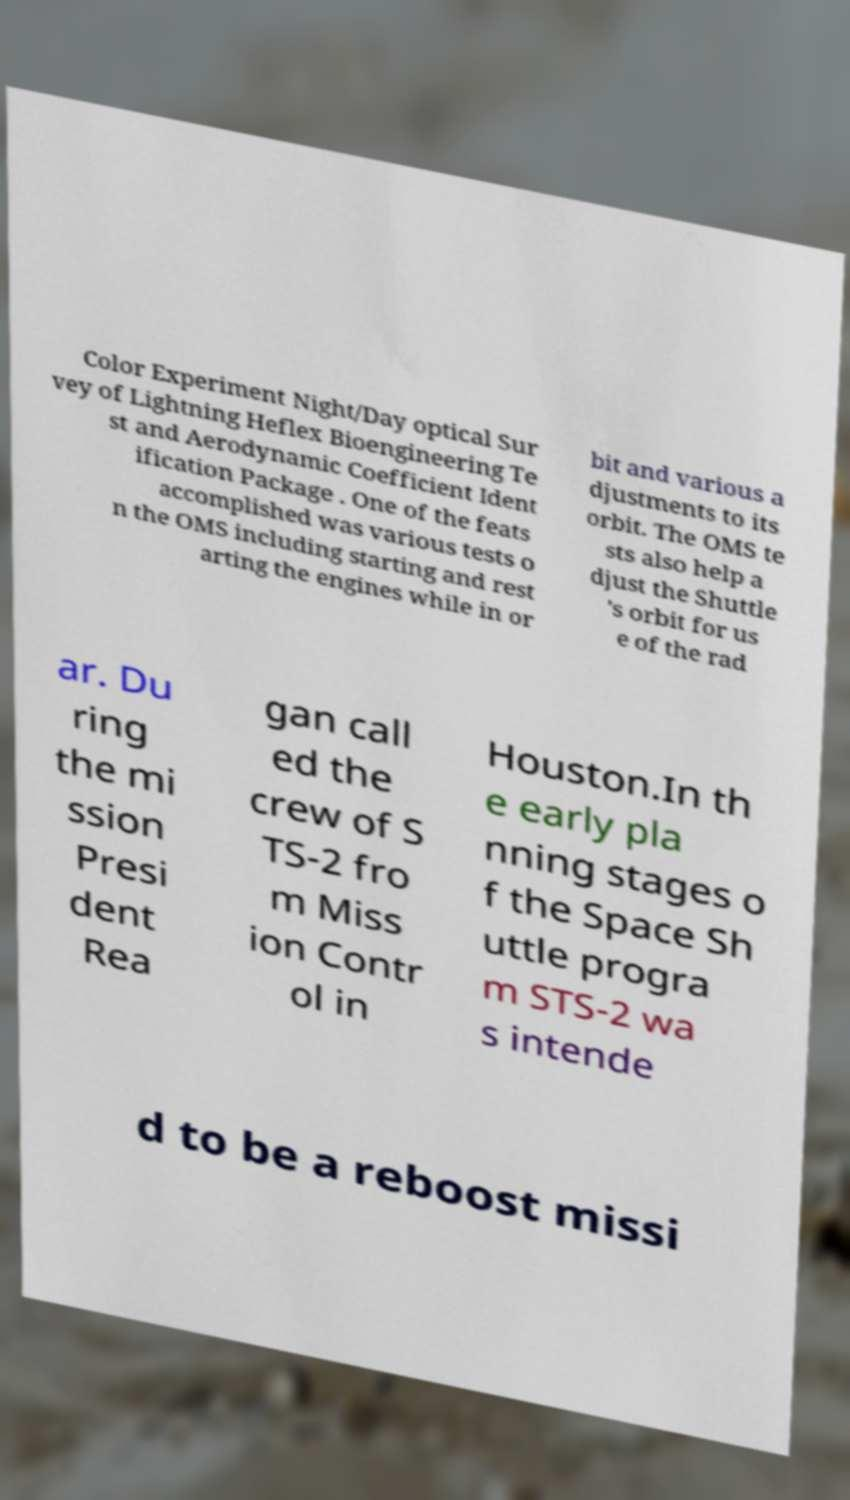What messages or text are displayed in this image? I need them in a readable, typed format. Color Experiment Night/Day optical Sur vey of Lightning Heflex Bioengineering Te st and Aerodynamic Coefficient Ident ification Package . One of the feats accomplished was various tests o n the OMS including starting and rest arting the engines while in or bit and various a djustments to its orbit. The OMS te sts also help a djust the Shuttle 's orbit for us e of the rad ar. Du ring the mi ssion Presi dent Rea gan call ed the crew of S TS-2 fro m Miss ion Contr ol in Houston.In th e early pla nning stages o f the Space Sh uttle progra m STS-2 wa s intende d to be a reboost missi 